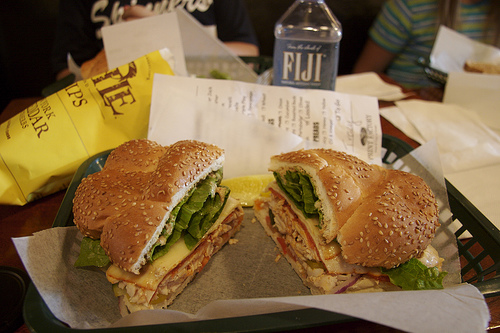<image>
Is the burger in front of the burger? No. The burger is not in front of the burger. The spatial positioning shows a different relationship between these objects. Is there a water above the sandwich? No. The water is not positioned above the sandwich. The vertical arrangement shows a different relationship. 